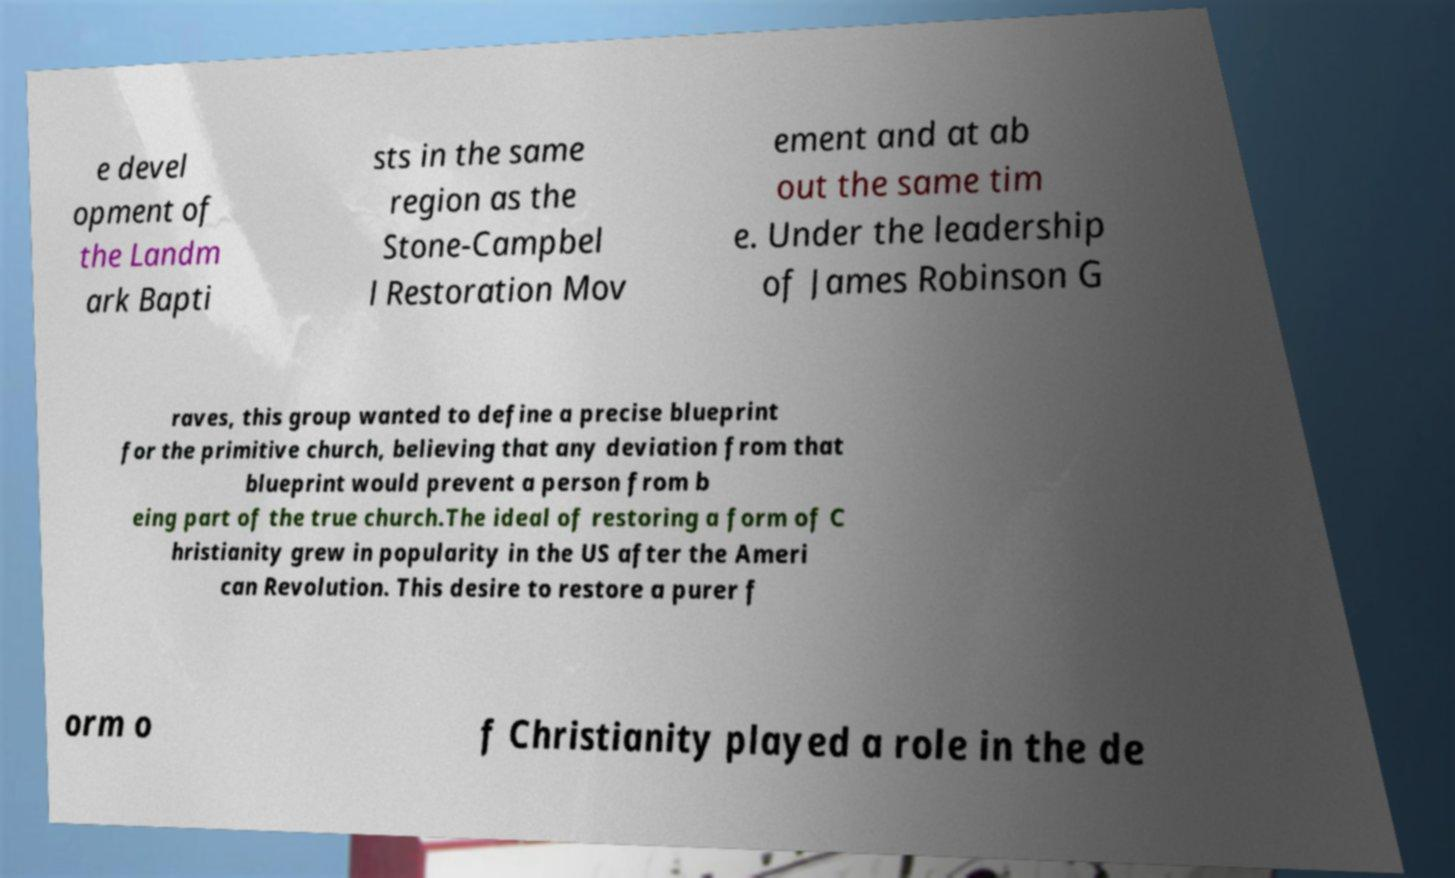There's text embedded in this image that I need extracted. Can you transcribe it verbatim? e devel opment of the Landm ark Bapti sts in the same region as the Stone-Campbel l Restoration Mov ement and at ab out the same tim e. Under the leadership of James Robinson G raves, this group wanted to define a precise blueprint for the primitive church, believing that any deviation from that blueprint would prevent a person from b eing part of the true church.The ideal of restoring a form of C hristianity grew in popularity in the US after the Ameri can Revolution. This desire to restore a purer f orm o f Christianity played a role in the de 